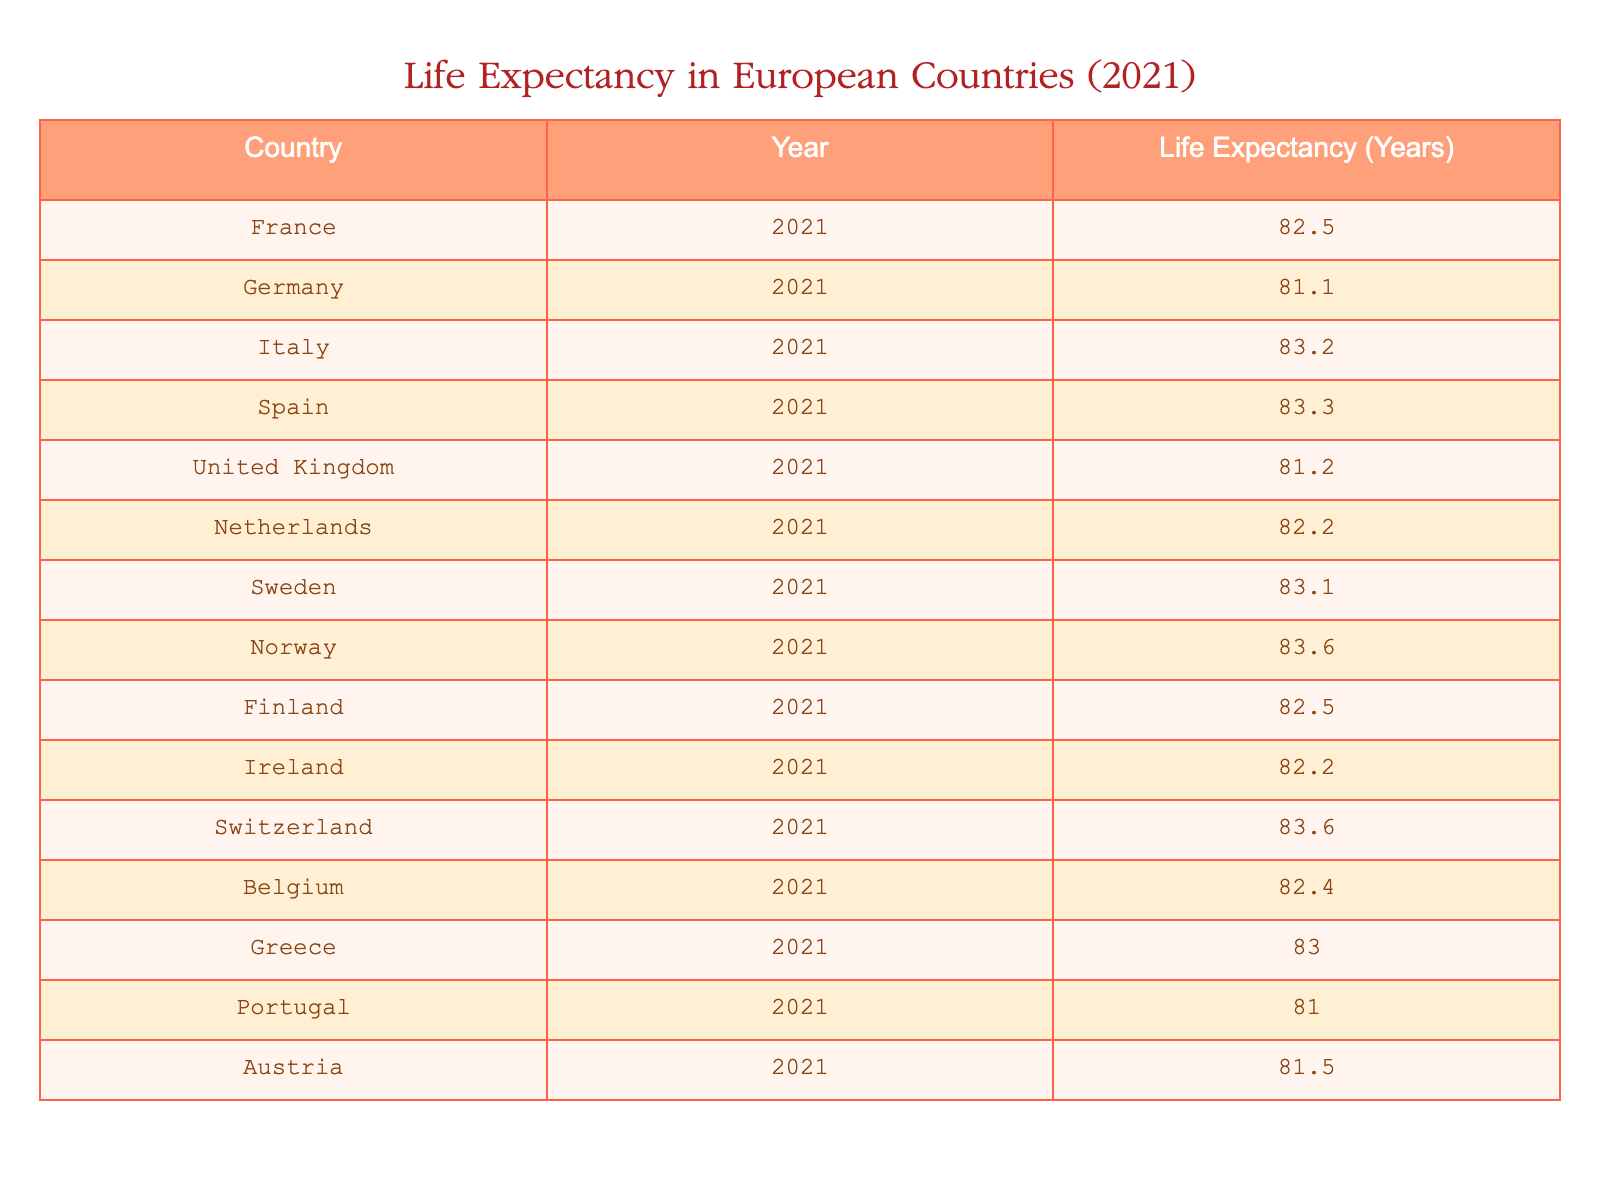What is the life expectancy in Spain? The table shows that the life expectancy for Spain in 2021 is listed directly in the respective row.
Answer: 83.3 Which country has the highest life expectancy in 2021? From the table, I can see that Norway and Switzerland both have the highest life expectancy of 83.6 years.
Answer: Norway and Switzerland How does the life expectancy in France compare to that in Italy? The life expectancy in France is 82.5 years, while in Italy it is 83.2 years. Since 83.2 is greater than 82.5, Italy has a higher life expectancy than France.
Answer: Italy has a higher life expectancy than France What is the average life expectancy of the countries listed in the table? First, I sum all the life expectancies: 82.5 + 81.1 + 83.2 + 83.3 + 81.2 + 82.2 + 83.1 + 83.6 + 82.5 + 82.2 + 83.6 + 83.0 + 81.0 + 81.5 = 1150.6. There are 14 countries, thus the average life expectancy is 1150.6 / 14 = 82.19.
Answer: 82.19 Is the life expectancy in the United Kingdom greater than that in Germany? The table shows the life expectancy in the UK is 81.2 years, while in Germany it is 81.1 years. Since 81.2 is greater than 81.1, the statement is true.
Answer: Yes Which country has a life expectancy closer to the average than the maximum value? From earlier we determined the maximum life expectancy is 83.6 years and the average is 82.19 years. We can calculate the difference: 83.6 - 82.19 = 1.41. Comparing to the differences of each country from the average, Germany at 81.1 is closest with a difference of 1.09 from the average.
Answer: Germany 